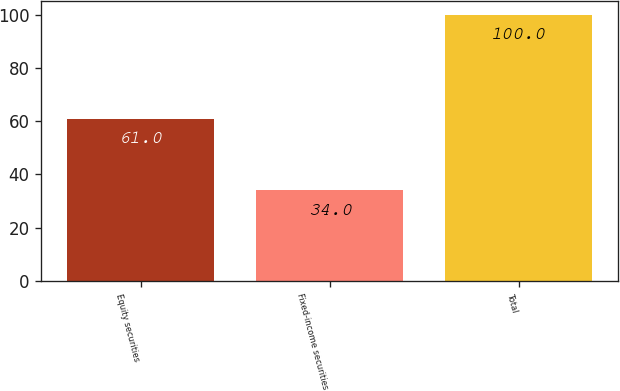Convert chart. <chart><loc_0><loc_0><loc_500><loc_500><bar_chart><fcel>Equity securities<fcel>Fixed-income securities<fcel>Total<nl><fcel>61<fcel>34<fcel>100<nl></chart> 